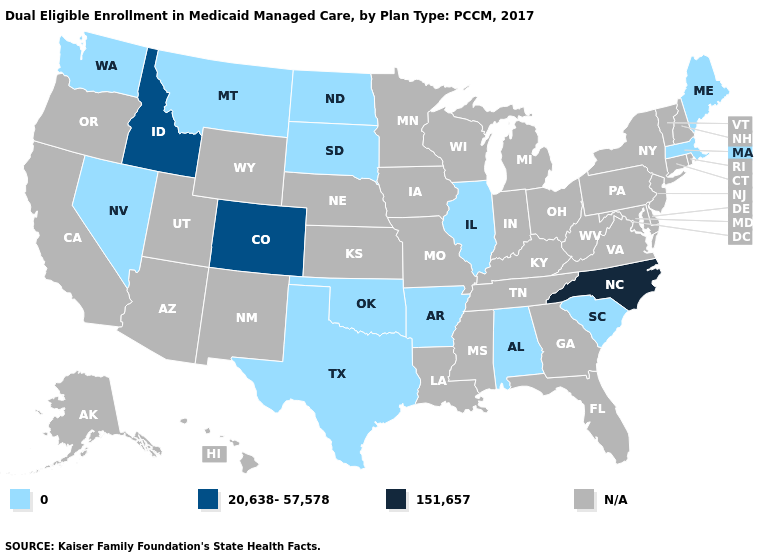What is the value of Ohio?
Be succinct. N/A. What is the value of South Carolina?
Be succinct. 0. Among the states that border Vermont , which have the lowest value?
Write a very short answer. Massachusetts. What is the value of Pennsylvania?
Quick response, please. N/A. Which states have the lowest value in the USA?
Write a very short answer. Alabama, Arkansas, Illinois, Maine, Massachusetts, Montana, Nevada, North Dakota, Oklahoma, South Carolina, South Dakota, Texas, Washington. What is the highest value in the USA?
Short answer required. 151,657. What is the value of Delaware?
Give a very brief answer. N/A. What is the lowest value in the Northeast?
Keep it brief. 0. Name the states that have a value in the range N/A?
Keep it brief. Alaska, Arizona, California, Connecticut, Delaware, Florida, Georgia, Hawaii, Indiana, Iowa, Kansas, Kentucky, Louisiana, Maryland, Michigan, Minnesota, Mississippi, Missouri, Nebraska, New Hampshire, New Jersey, New Mexico, New York, Ohio, Oregon, Pennsylvania, Rhode Island, Tennessee, Utah, Vermont, Virginia, West Virginia, Wisconsin, Wyoming. Does Colorado have the lowest value in the West?
Short answer required. No. Is the legend a continuous bar?
Keep it brief. No. Name the states that have a value in the range N/A?
Keep it brief. Alaska, Arizona, California, Connecticut, Delaware, Florida, Georgia, Hawaii, Indiana, Iowa, Kansas, Kentucky, Louisiana, Maryland, Michigan, Minnesota, Mississippi, Missouri, Nebraska, New Hampshire, New Jersey, New Mexico, New York, Ohio, Oregon, Pennsylvania, Rhode Island, Tennessee, Utah, Vermont, Virginia, West Virginia, Wisconsin, Wyoming. 